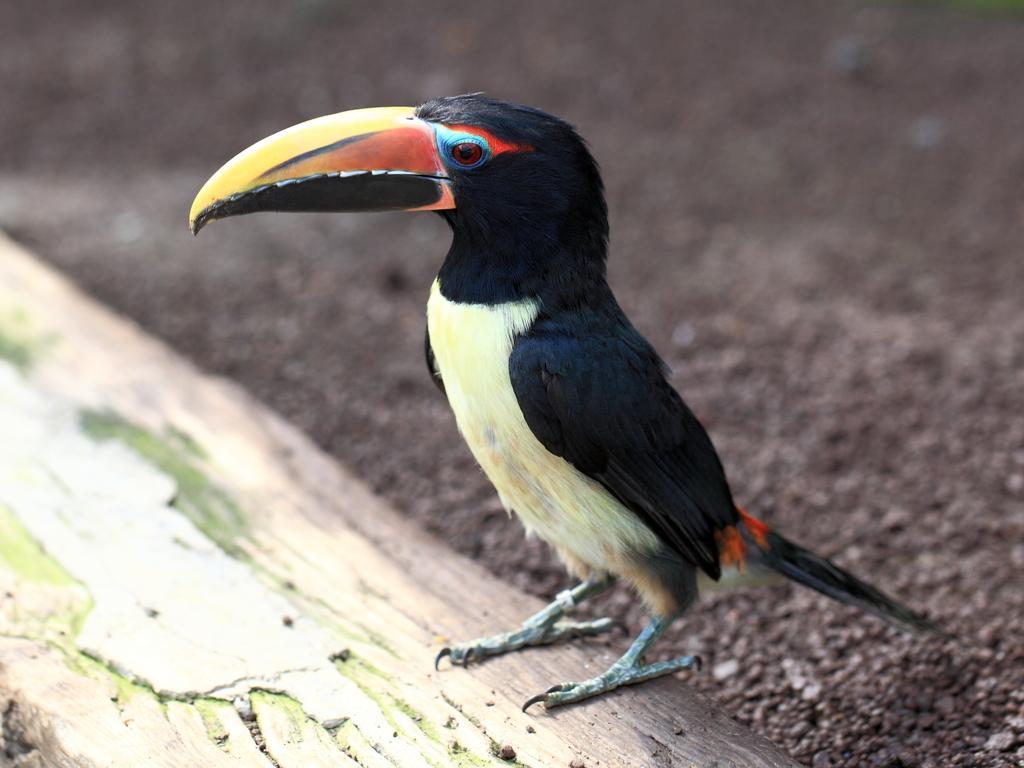Can you describe this image briefly? In this image I can see a bird on a tree trunk and sand. This image is taken may be during a day. 